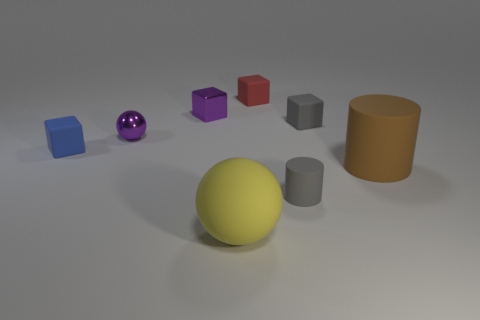Is the shiny sphere the same color as the metallic cube?
Your response must be concise. Yes. There is a object that is in front of the big brown cylinder and on the left side of the red object; what is its material?
Offer a very short reply. Rubber. The yellow rubber ball has what size?
Ensure brevity in your answer.  Large. There is a red matte cube right of the ball behind the large yellow rubber thing; how many matte blocks are to the right of it?
Give a very brief answer. 1. There is a tiny purple thing that is behind the purple object in front of the small metal block; what shape is it?
Your answer should be very brief. Cube. There is a shiny thing that is in front of the tiny metallic cube; what color is it?
Provide a succinct answer. Purple. The ball that is behind the large object on the right side of the big yellow rubber sphere on the right side of the tiny metal cube is made of what material?
Your answer should be very brief. Metal. There is a rubber cylinder that is to the right of the gray thing that is in front of the brown matte object; how big is it?
Keep it short and to the point. Large. The other tiny shiny object that is the same shape as the small blue thing is what color?
Make the answer very short. Purple. How many shiny cubes have the same color as the tiny metallic ball?
Your response must be concise. 1. 